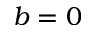Convert formula to latex. <formula><loc_0><loc_0><loc_500><loc_500>b = 0</formula> 